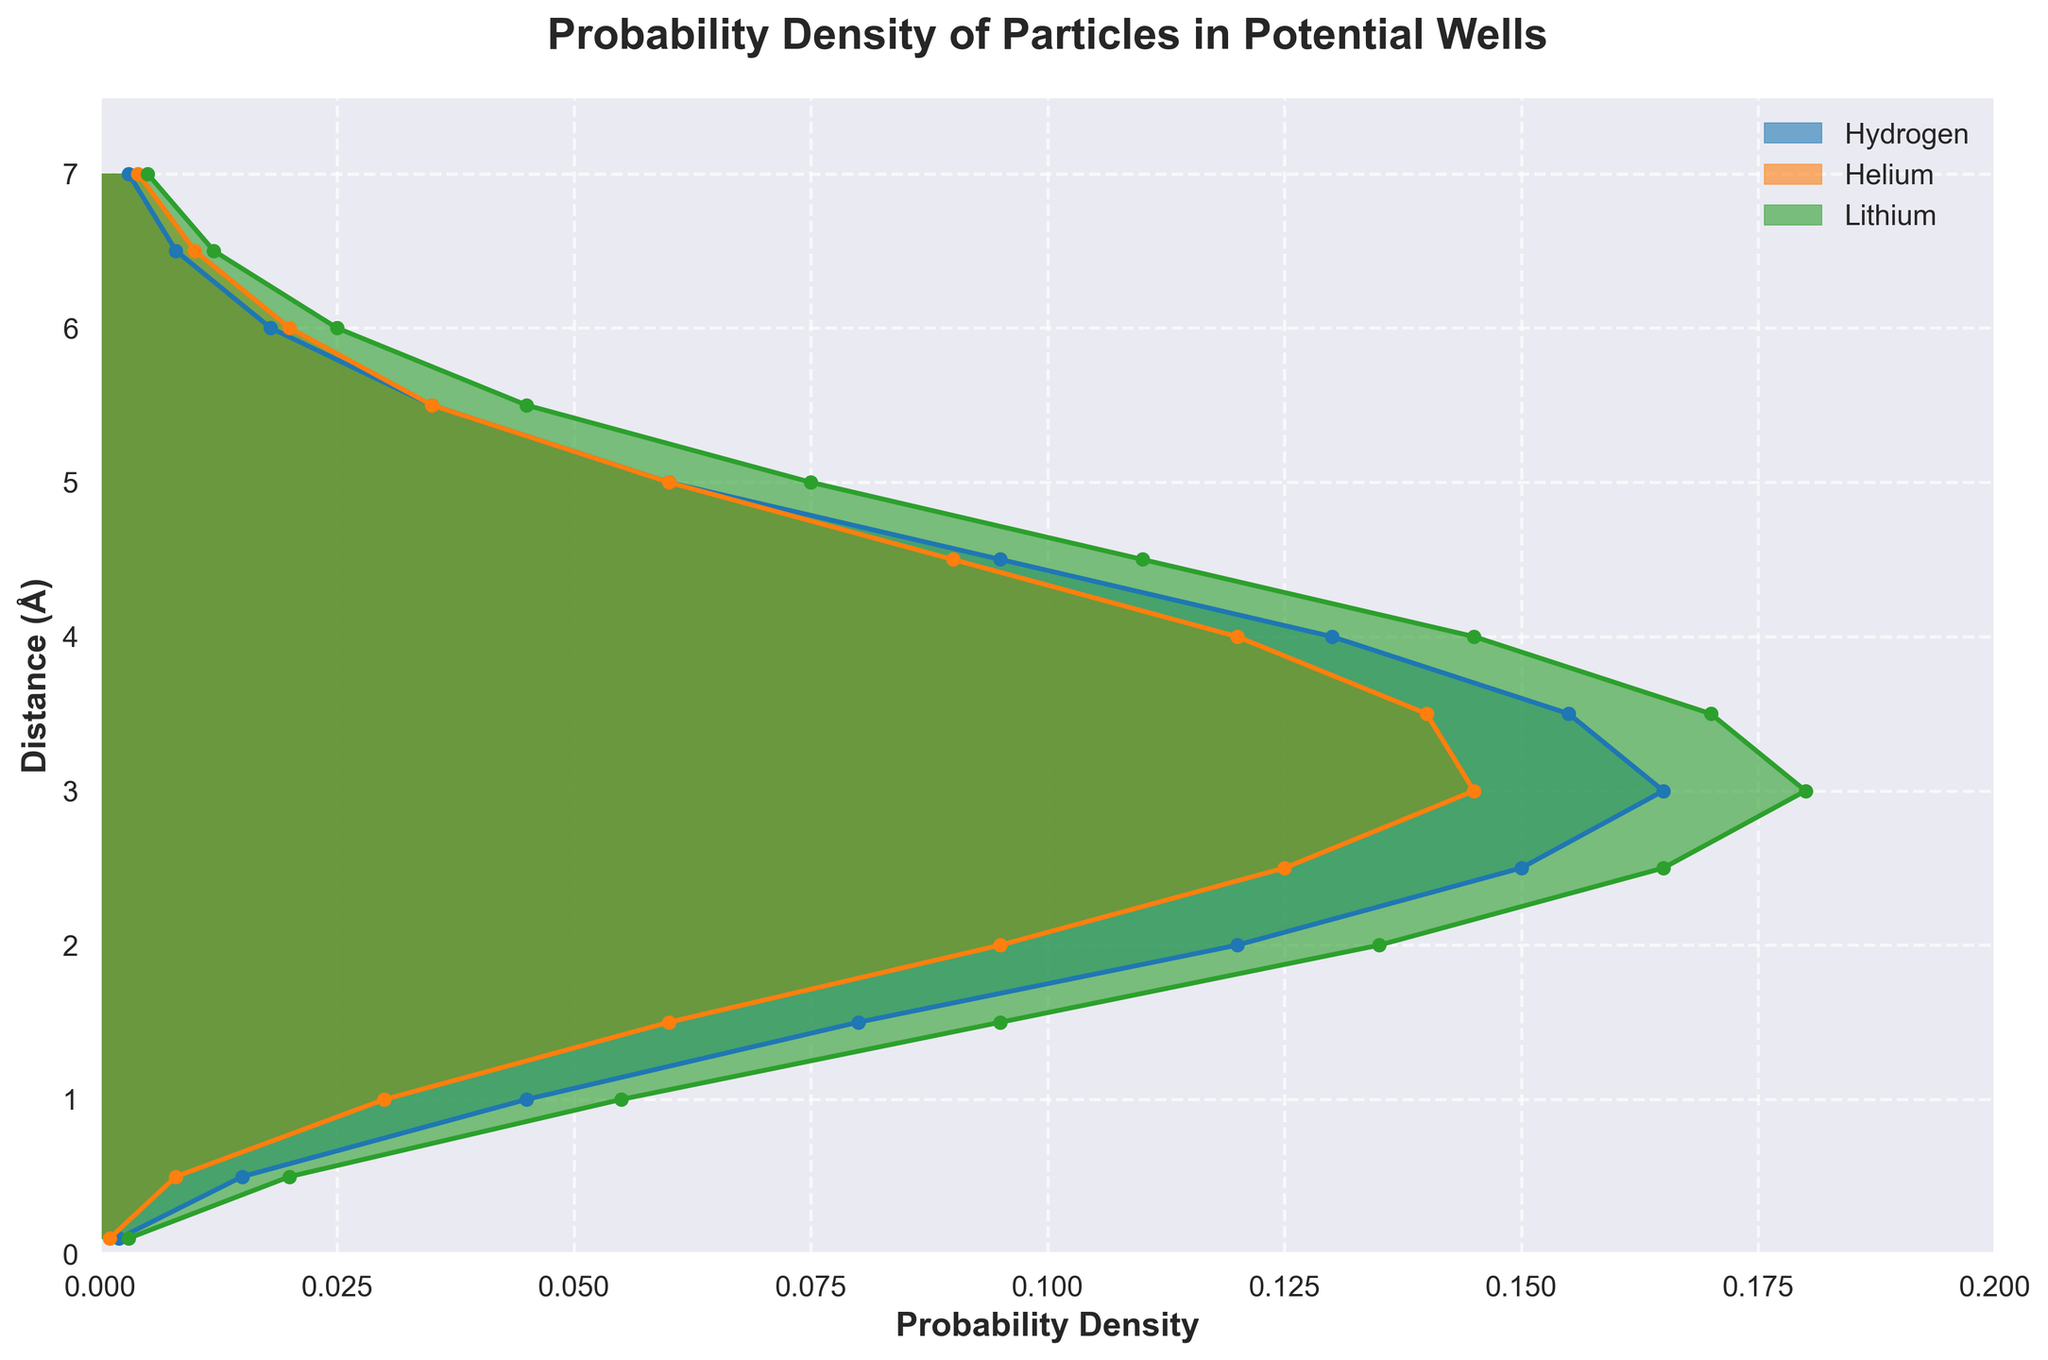What's the title of the figure? The title of the figure is located at the top and reads: "Probability Density of Particles in Potential Wells".
Answer: Probability Density of Particles in Potential Wells What is the y-axis label? The y-axis label, which describes what the vertical axis represents, reads: "Distance (Å)".
Answer: Distance (Å) At what distance is the probability density of Lithium the highest? By looking at the plot for Lithium (green color), the peak occurs at the distance where the curve reaches its maximum height. This occurs at around 3.0 Å.
Answer: 3.0 Å How many elements are represented in the figure, and what are they? The legend in the figure identifies the three elements represented by different colors. These elements are Hydrogen, Helium, and Lithium.
Answer: 3 elements: Hydrogen, Helium, Lithium What is the probability density of Helium at a distance of 3.5 Å? To find this, locate the vertical (3.5 Å) on the y-axis and trace horizontally until you hit the Helium curve (orange color). Then read the corresponding probability density value on the x-axis, which is approximately 0.14.
Answer: 0.14 At which distance does Helium have twice the probability density value of Hydrogen? For this, we need to compare the curves of Helium and Hydrogen. At a distance of around 3.0 Å, the probability density of Helium is approximately 0.145, which is roughly double the probability density of Hydrogen (0.065 * 2 ≈ 0.145).
Answer: 3.0 Å When is the probability density of Hydrogen higher than Helium? By examining the plots, the probability density of Hydrogen (blue) surpasses Helium (orange) briefly between 3.5 Å and 4.0 Å.
Answer: Between 3.5 Å and 4.0 Å What is the range of distances where the density values are above 0.1 for all three elements? First identify regions where the curves for Hydrogen, Helium, and Lithium all exceed 0.1 on the x-axis. This occurs within the distance range approximately between 2.0 Å and 4.0 Å.
Answer: 2.0 Å to 4.0 Å Which element shows the steepest increase in probability density from 0.5 Å to 2.0 Å? The steepest increase can be deduced by the steepness of the slope during the interval. Lithium (green) shows a steeper increase from around 0.02 to 0.135 compared to Hydrogen and Helium.
Answer: Lithium At what distance does the probability density of  Hydrogen equal the density of Lithium? By comparing their curves, the Hydrogen (blue) and Lithium (green) curves intersect at around 5.5 Å where both have the same density value of roughly 0.035.
Answer: 5.5 Å 